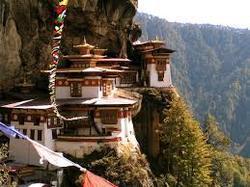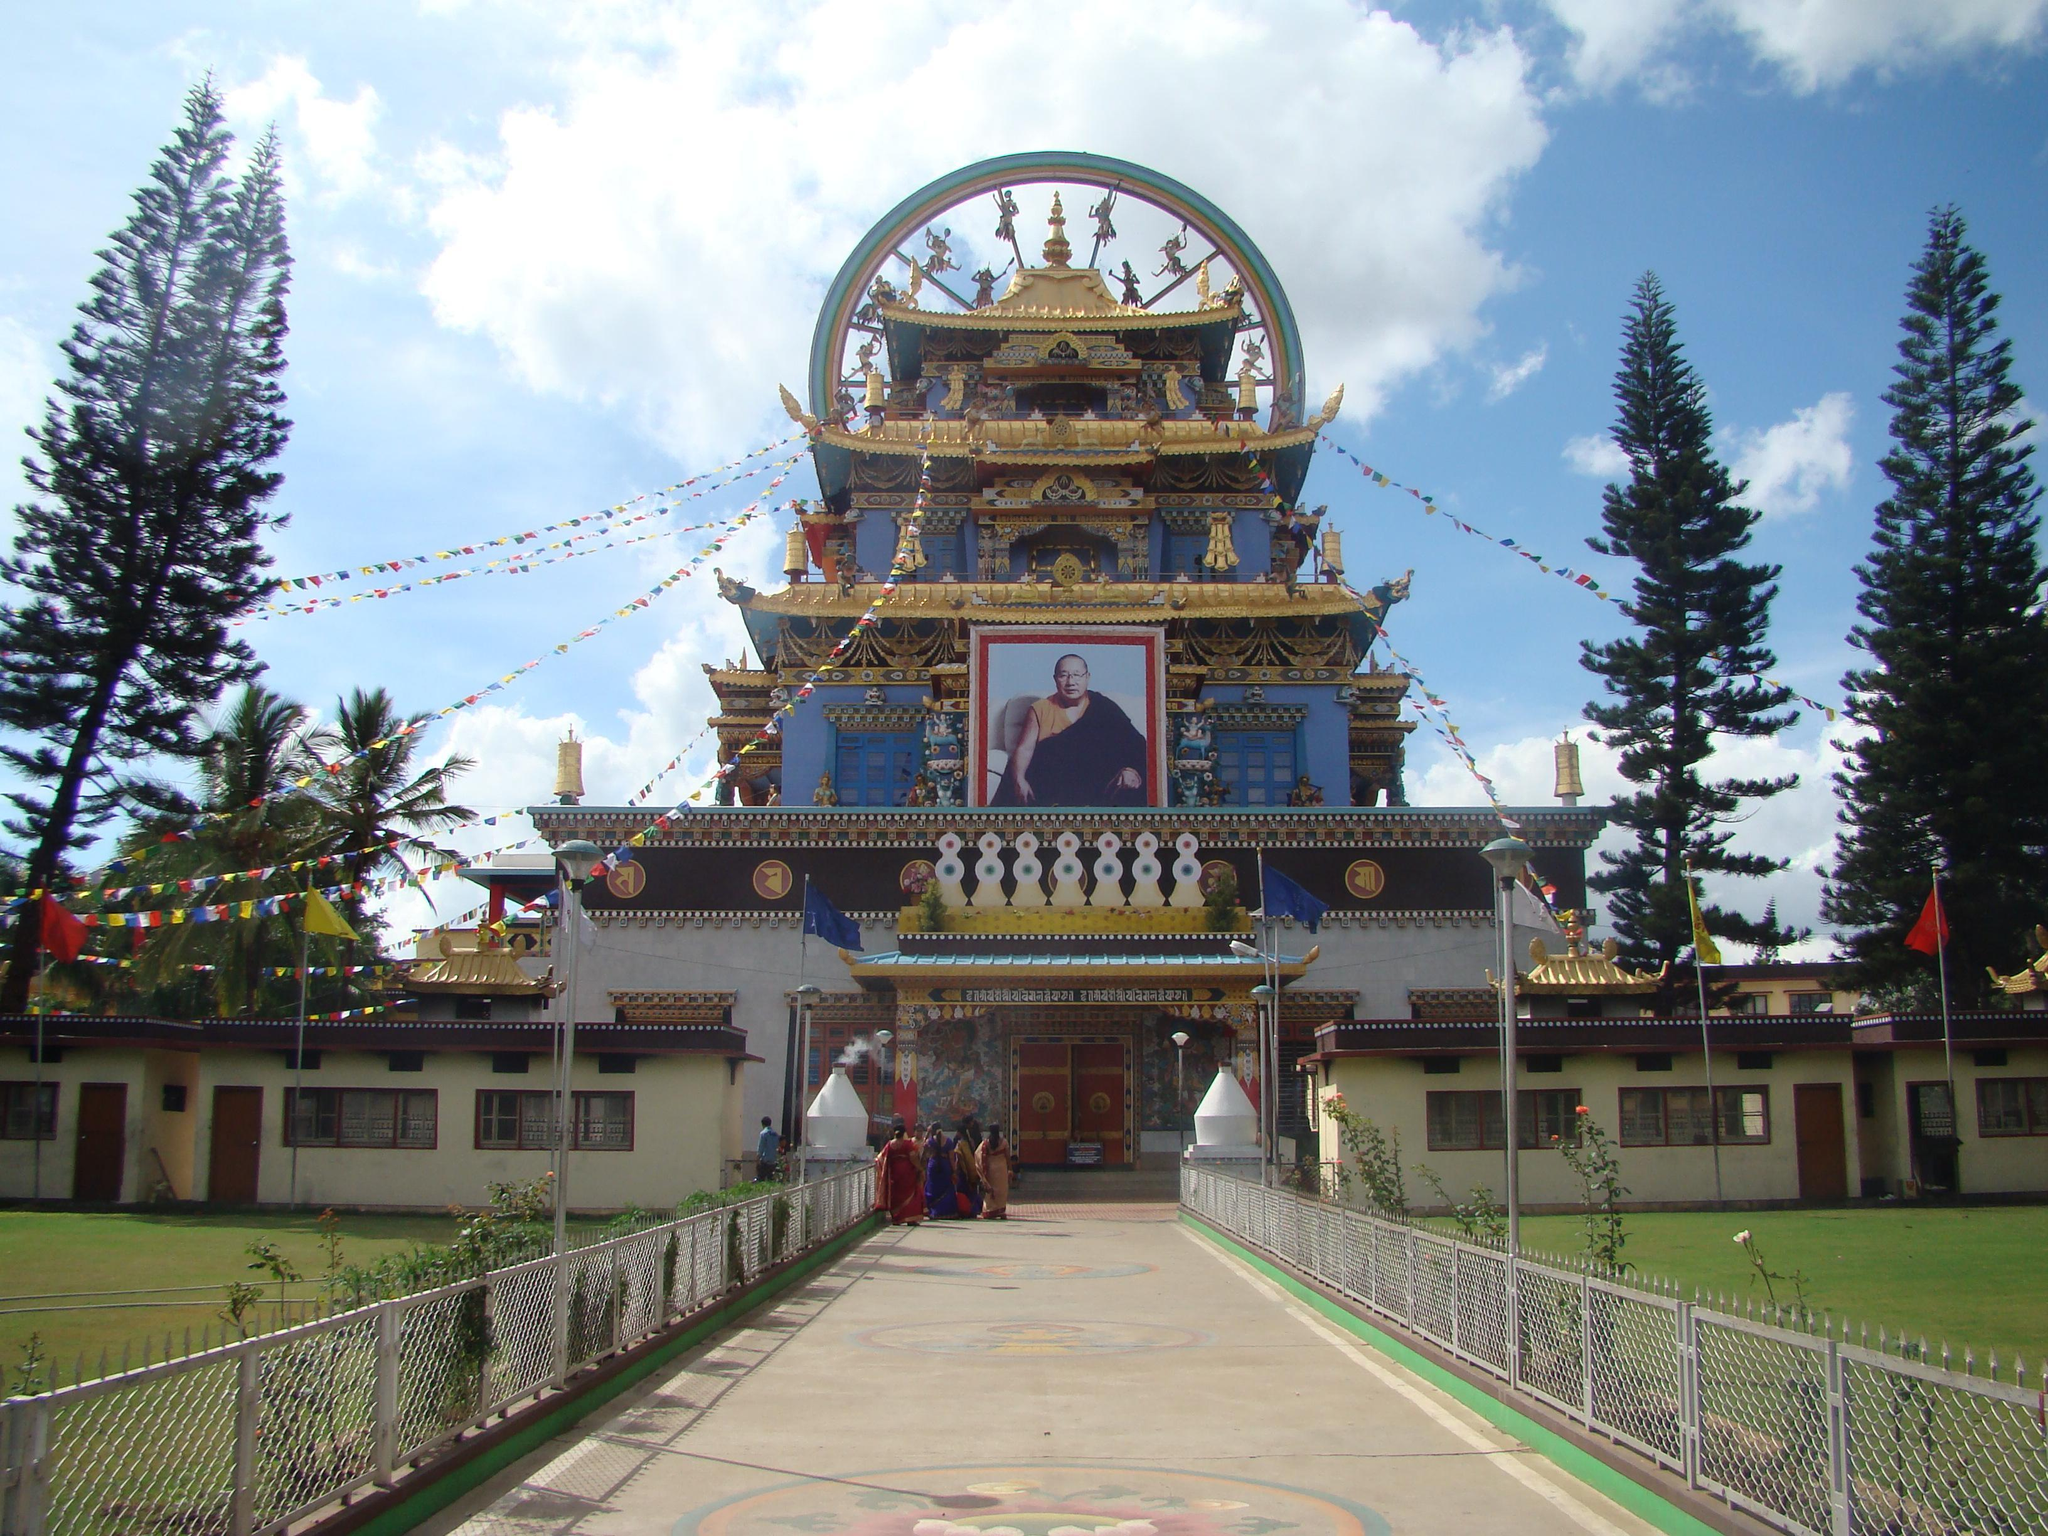The first image is the image on the left, the second image is the image on the right. Assess this claim about the two images: "An image shows a temple built in tiers that follow the shape of a side of a mountain.". Correct or not? Answer yes or no. Yes. The first image is the image on the left, the second image is the image on the right. Examine the images to the left and right. Is the description "In one of images, there is a temple built on the side of a mountain." accurate? Answer yes or no. Yes. 